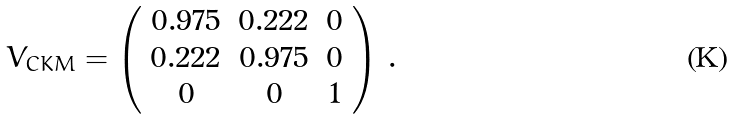Convert formula to latex. <formula><loc_0><loc_0><loc_500><loc_500>V _ { C K M } = \left ( \begin{array} { c c c } { 0 . 9 7 5 } & { 0 . 2 2 2 } & { 0 } \\ { 0 . 2 2 2 } & { 0 . 9 7 5 } & { 0 } \\ { 0 } & { 0 } & { 1 } \end{array} \right ) \, .</formula> 